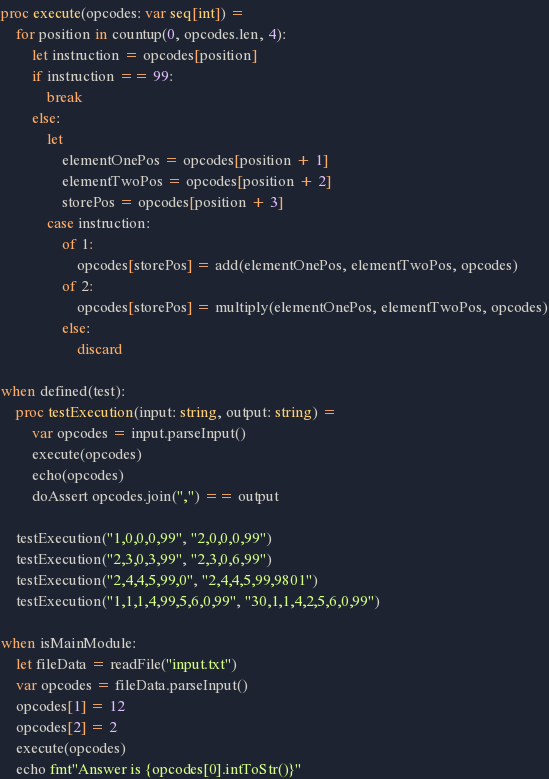Convert code to text. <code><loc_0><loc_0><loc_500><loc_500><_Nim_>
proc execute(opcodes: var seq[int]) =
    for position in countup(0, opcodes.len, 4):
        let instruction = opcodes[position]
        if instruction == 99:
            break
        else:
            let
                elementOnePos = opcodes[position + 1]
                elementTwoPos = opcodes[position + 2]
                storePos = opcodes[position + 3]
            case instruction:
                of 1:
                    opcodes[storePos] = add(elementOnePos, elementTwoPos, opcodes)
                of 2:
                    opcodes[storePos] = multiply(elementOnePos, elementTwoPos, opcodes)
                else:
                    discard

when defined(test):
    proc testExecution(input: string, output: string) =
        var opcodes = input.parseInput()
        execute(opcodes)
        echo(opcodes)
        doAssert opcodes.join(",") == output
    
    testExecution("1,0,0,0,99", "2,0,0,0,99")
    testExecution("2,3,0,3,99", "2,3,0,6,99")
    testExecution("2,4,4,5,99,0", "2,4,4,5,99,9801")
    testExecution("1,1,1,4,99,5,6,0,99", "30,1,1,4,2,5,6,0,99")

when isMainModule:
    let fileData = readFile("input.txt")
    var opcodes = fileData.parseInput()
    opcodes[1] = 12
    opcodes[2] = 2
    execute(opcodes)
    echo fmt"Answer is {opcodes[0].intToStr()}"
</code> 